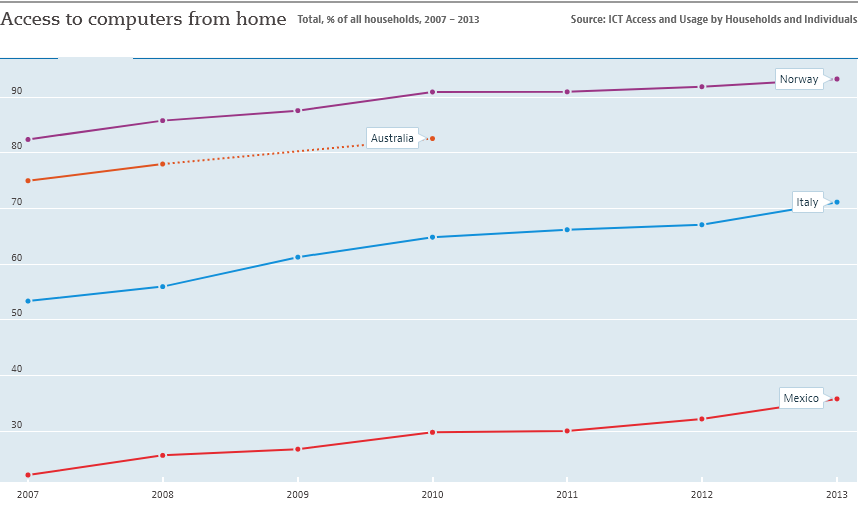How does Italy's computer access from home compare to that of Norway? On the graph, we observe that Norway consistently maintains a higher percentage of household computer access than Italy throughout the depicted time frame of 2007 to 2013. Norway's access starts above 80% and climbs closer to 95%, while Italy's begins around 50% and reaches just over 60% by 2013. Both countries show growth, but Norway's level of access is significantly higher. 